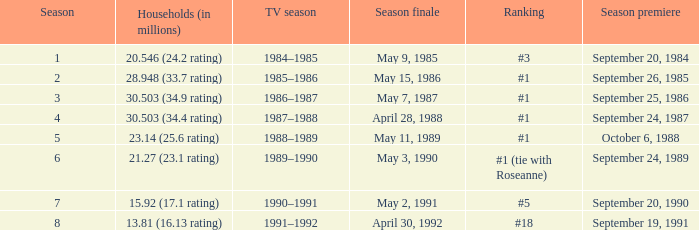Which TV season has Households (in millions) of 30.503 (34.9 rating)? 1986–1987. 